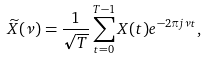Convert formula to latex. <formula><loc_0><loc_0><loc_500><loc_500>\widetilde { X } ( \nu ) = \frac { 1 } { \sqrt { T } } \sum _ { t = 0 } ^ { T - 1 } X ( t ) e ^ { - 2 \pi j \nu t } ,</formula> 